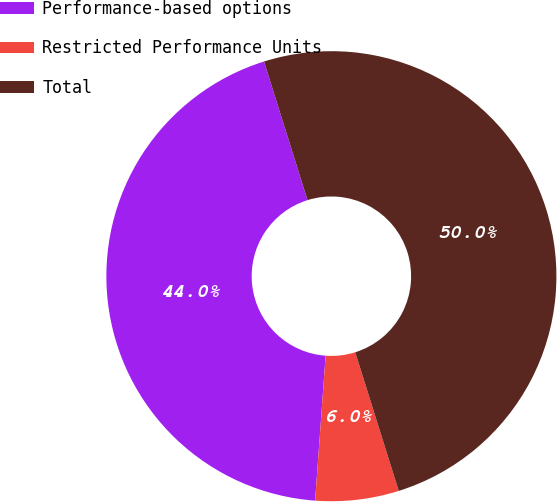Convert chart. <chart><loc_0><loc_0><loc_500><loc_500><pie_chart><fcel>Performance-based options<fcel>Restricted Performance Units<fcel>Total<nl><fcel>44.01%<fcel>5.99%<fcel>50.0%<nl></chart> 